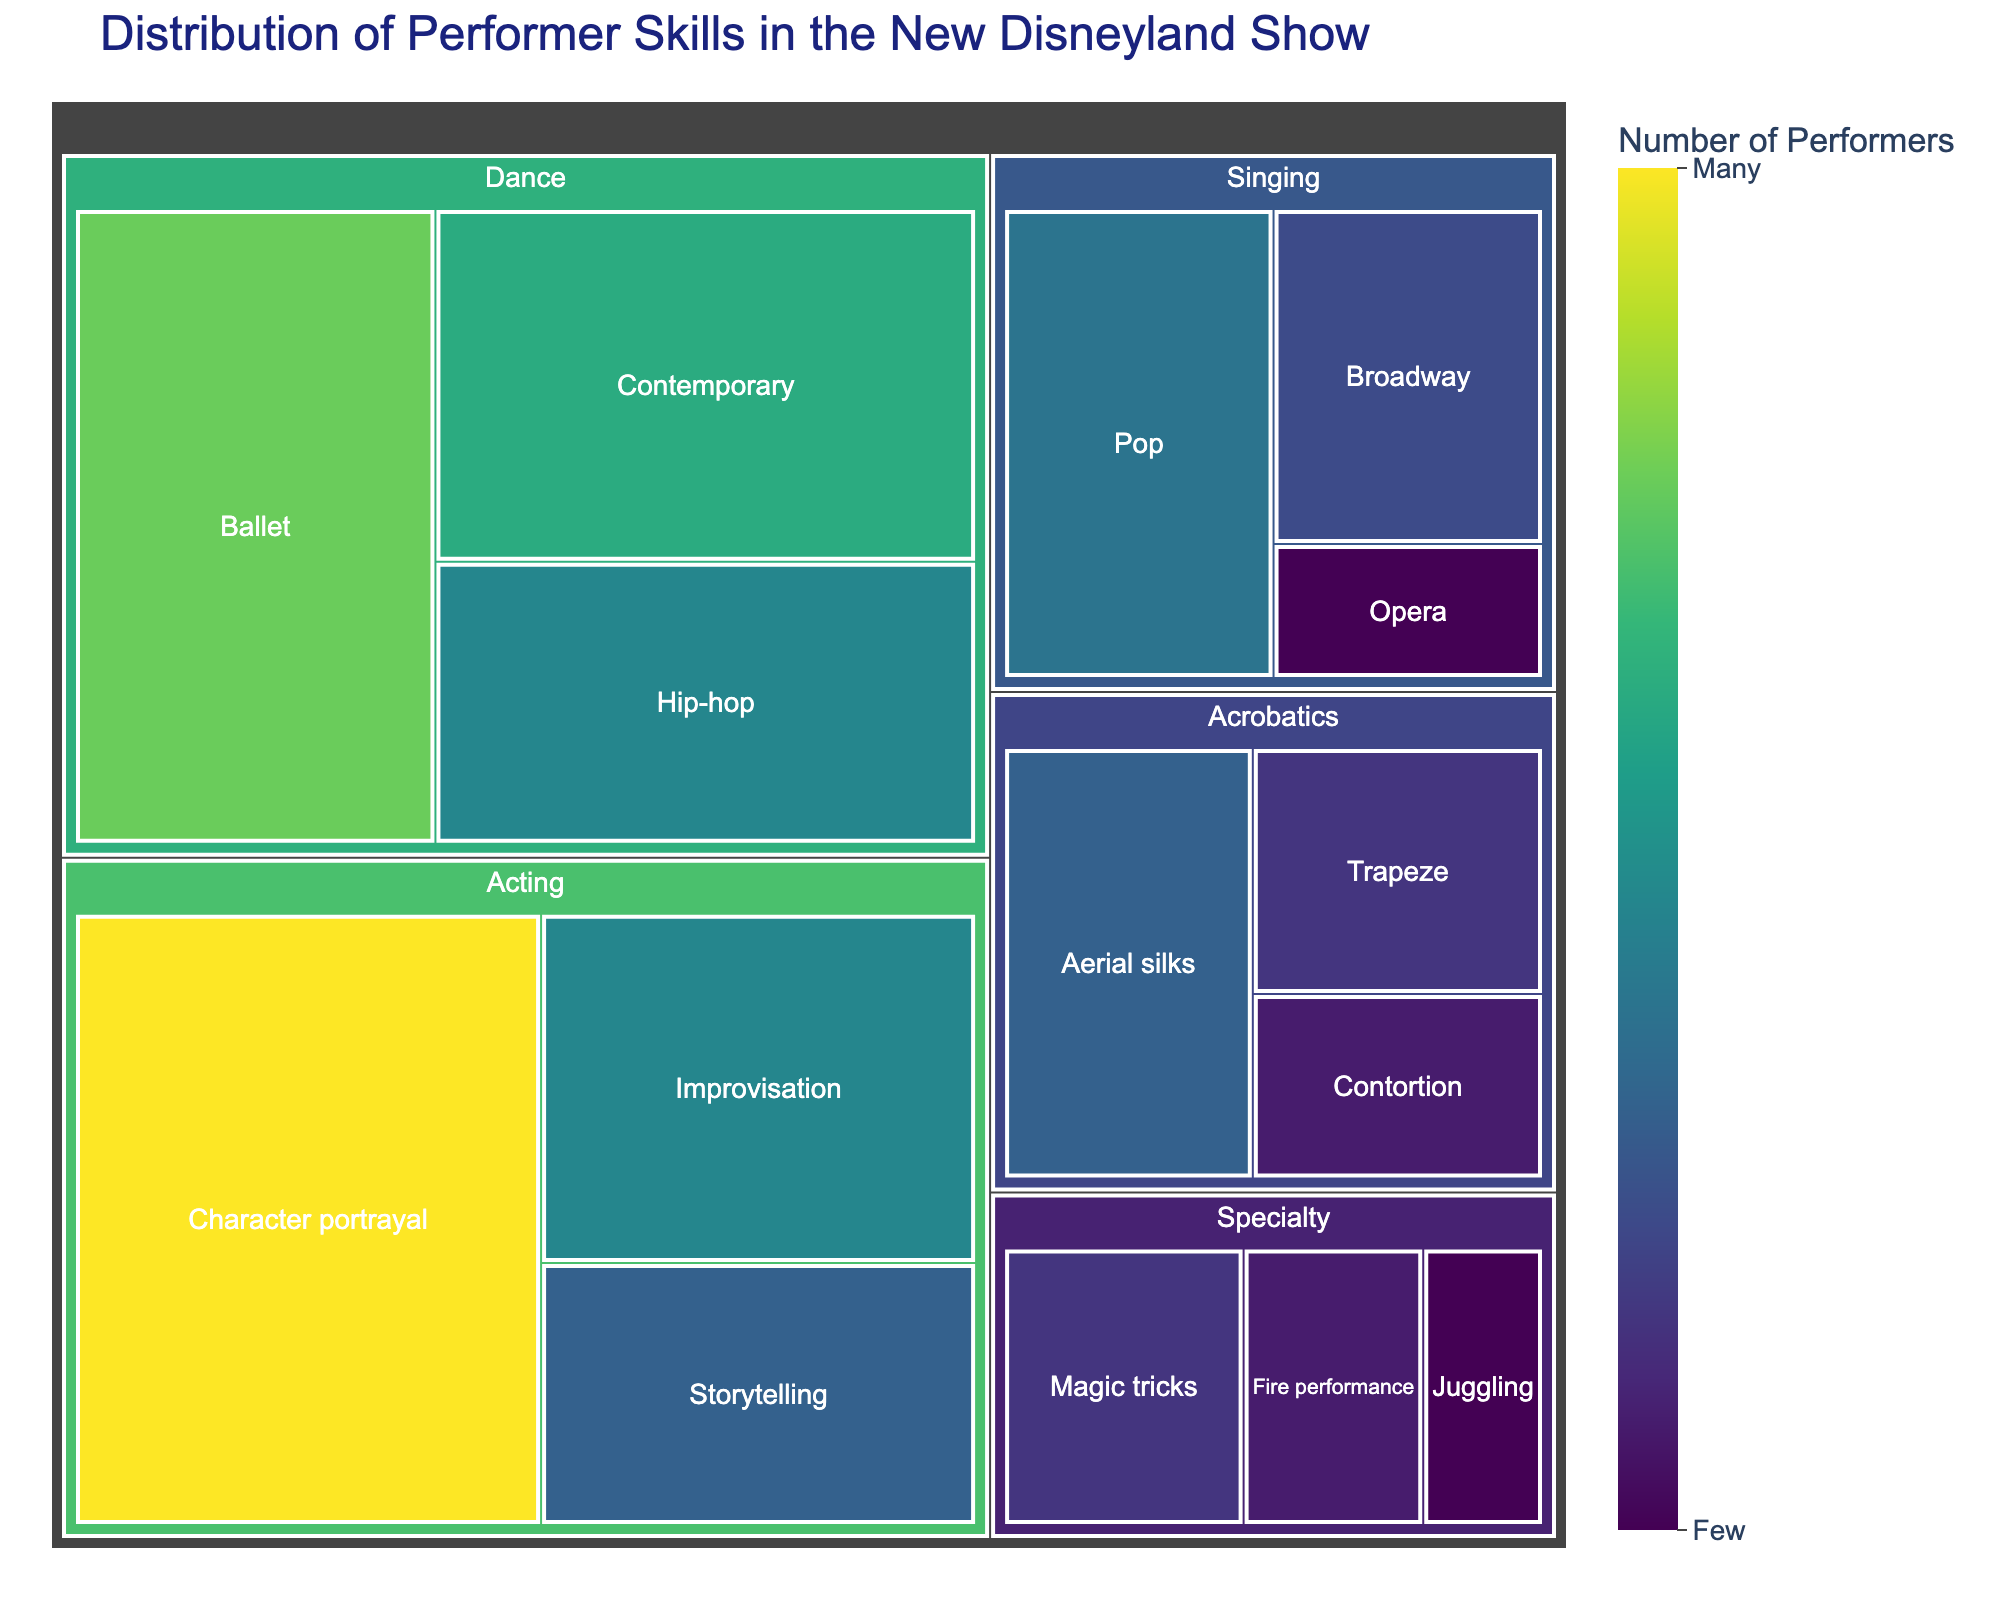What is the total number of "Performers" in the "Dance" category? To find the total number of performers in the Dance category, sum up the performers for each skill: Ballet (12), Hip-hop (8), and Contemporary (10). So, 12 + 8 + 10 = 30.
Answer: 30 Which performance type has the highest number of "Performers"? Look for the performance type with the largest number in the figure. "Acting" has Character portrayal (15), Improvisation (8), and Storytelling (6), making it the highest with 15 + 8 + 6 = 29 performers.
Answer: Acting How many more performers does "Character portrayal" have compared to "Pop Singing"? "Character portrayal" has 15 performers while "Pop Singing" has 7. Calculate the difference: 15 - 7 = 8.
Answer: 8 What is the difference in the number of "Performers" between "Ballet" and "Magic tricks"? "Ballet" has 12 performers, and "Magic tricks" has 4. Calculate the difference: 12 - 4 = 8.
Answer: 8 Which skill has the smallest number of "Performers"? Identify the smallest value in the 'Performers' data. "Juggling" has only 2 performers, the smallest number in the dataset.
Answer: Juggling What is the total number of "Performers" in the "Acrobatics" category? Sum the number of performers for Aerial silks (6), Trapeze (4), and Contortion (3). So, 6 + 4 + 3 = 13.
Answer: 13 Are there more "Performers" in "Singing" or "Specialty" categories? Add the performers in each category: Singing (7+5+2 = 14) and Specialty (3+2+4 = 9). Singing (14) has more than Specialty (9).
Answer: Singing What is the average number of "Performers" in the "Improvisation" and "Aerial Silks" skills? Add the number of performers for Improvisation (8) and Aerial silks (6), then divide by 2. So, (8 + 6) / 2 = 7.
Answer: 7 Which performance type has the most varied range of skills based on "Performers" count? Check the performance types and their skills. 'Acting' has 15 (Character portrayal), 8 (Improvisation), and 6 (Storytelling), giving a wide range from 6 to 15.
Answer: Acting How many more "Performers" are in "Dance" compared to "Singing"? Total performers in Dance (30) and Singing (14). Calculate the difference: 30 - 14 = 16.
Answer: 16 